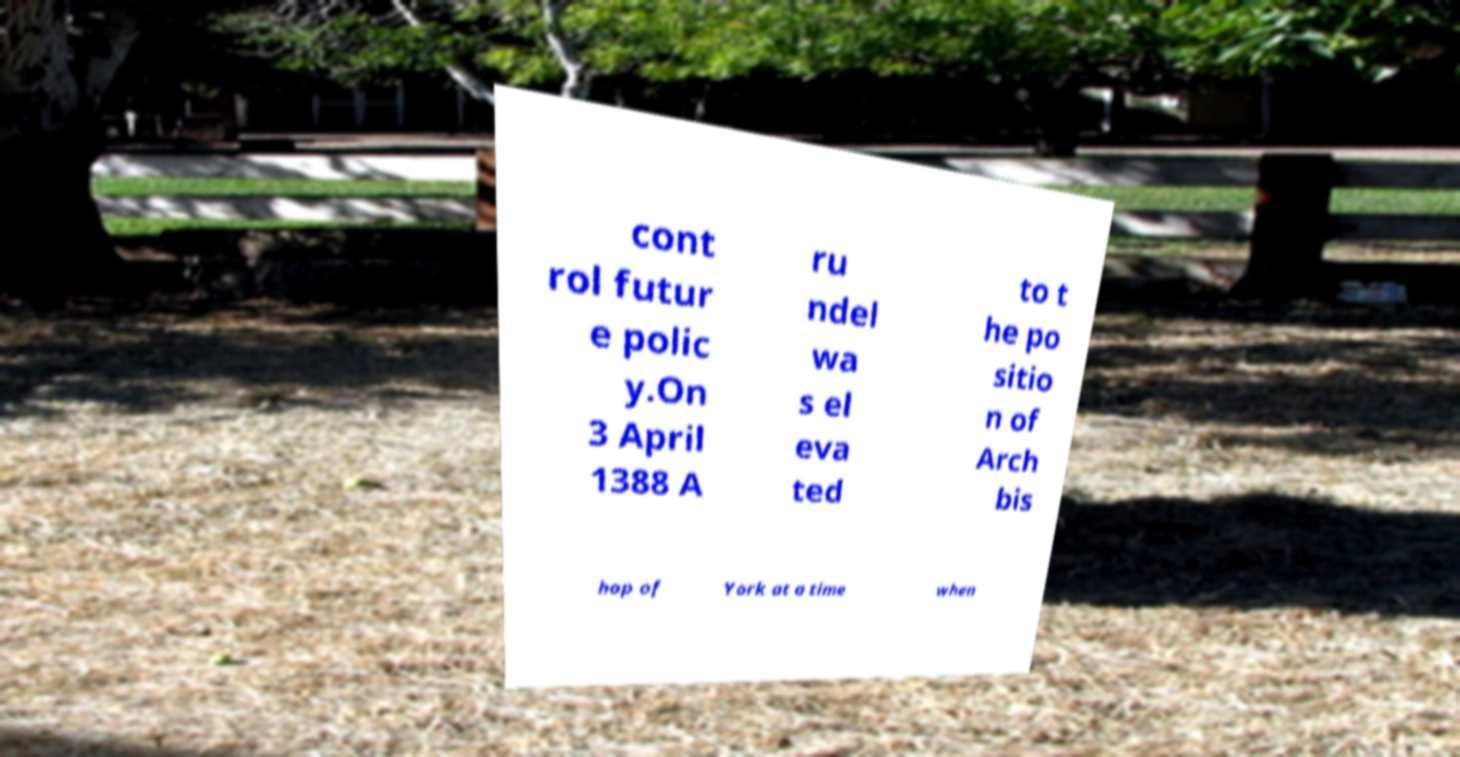For documentation purposes, I need the text within this image transcribed. Could you provide that? cont rol futur e polic y.On 3 April 1388 A ru ndel wa s el eva ted to t he po sitio n of Arch bis hop of York at a time when 